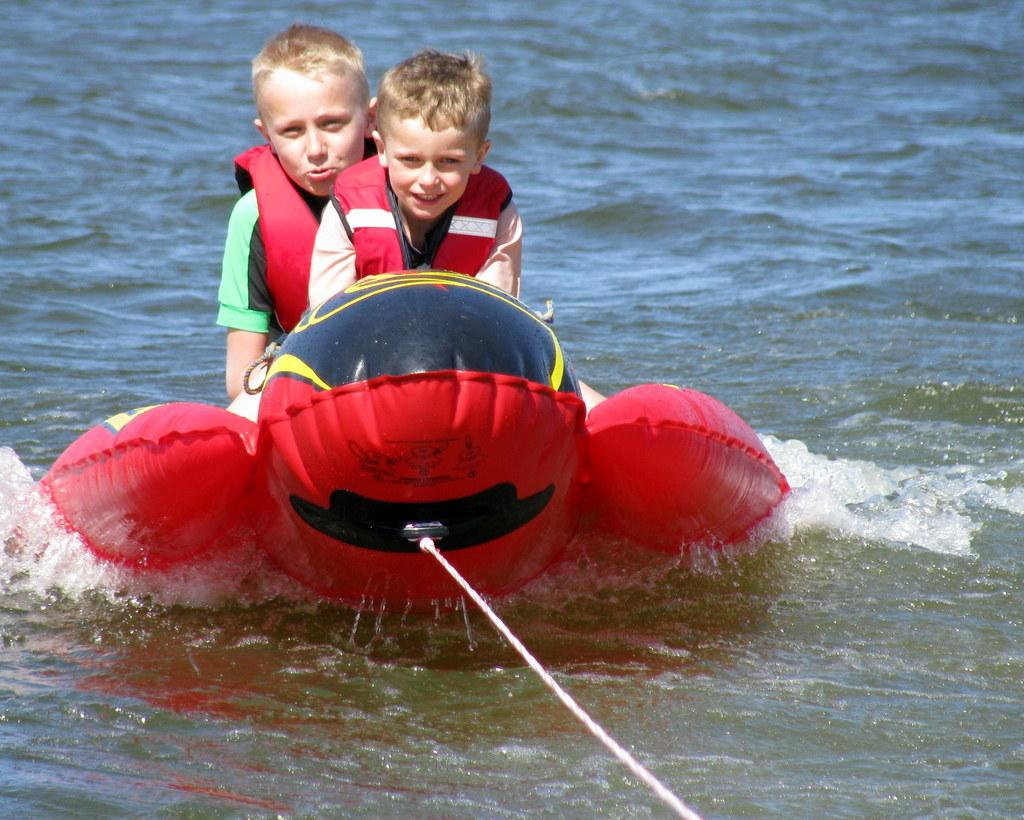How many kids are in the image? There are two kids in the image. What are the kids doing in the image? The kids are sitting on an object on water. What is attached to the object on which the kids are sitting? A white rope is tied to the object. What are the kids wearing for safety? The kids are wearing red life jackets. What historical event is depicted in the image? The image does not depict any historical event; it shows two kids sitting on an object on water. What type of wire can be seen connecting the kids to the object? There is no wire present in the image; a white rope is tied to the object. 